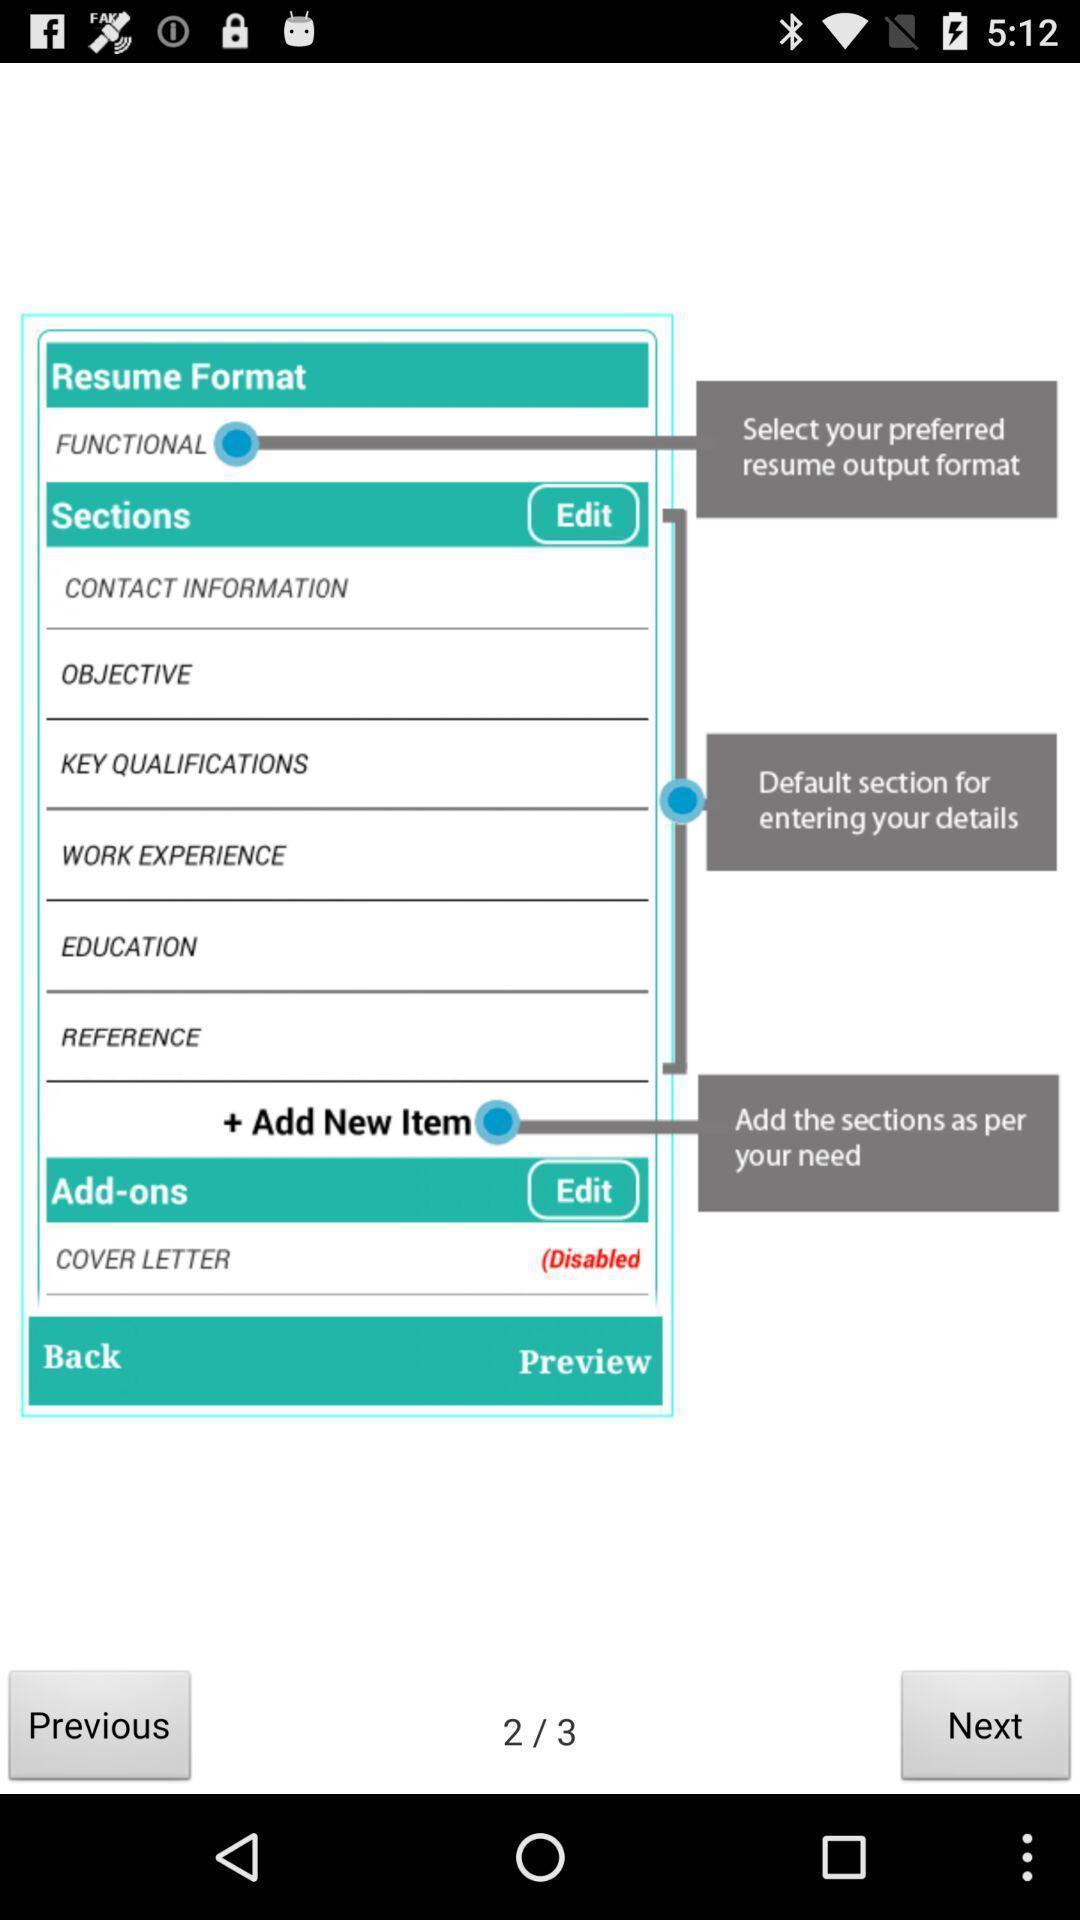Tell me what you see in this picture. Screen displaying demo instructions to access an application. 